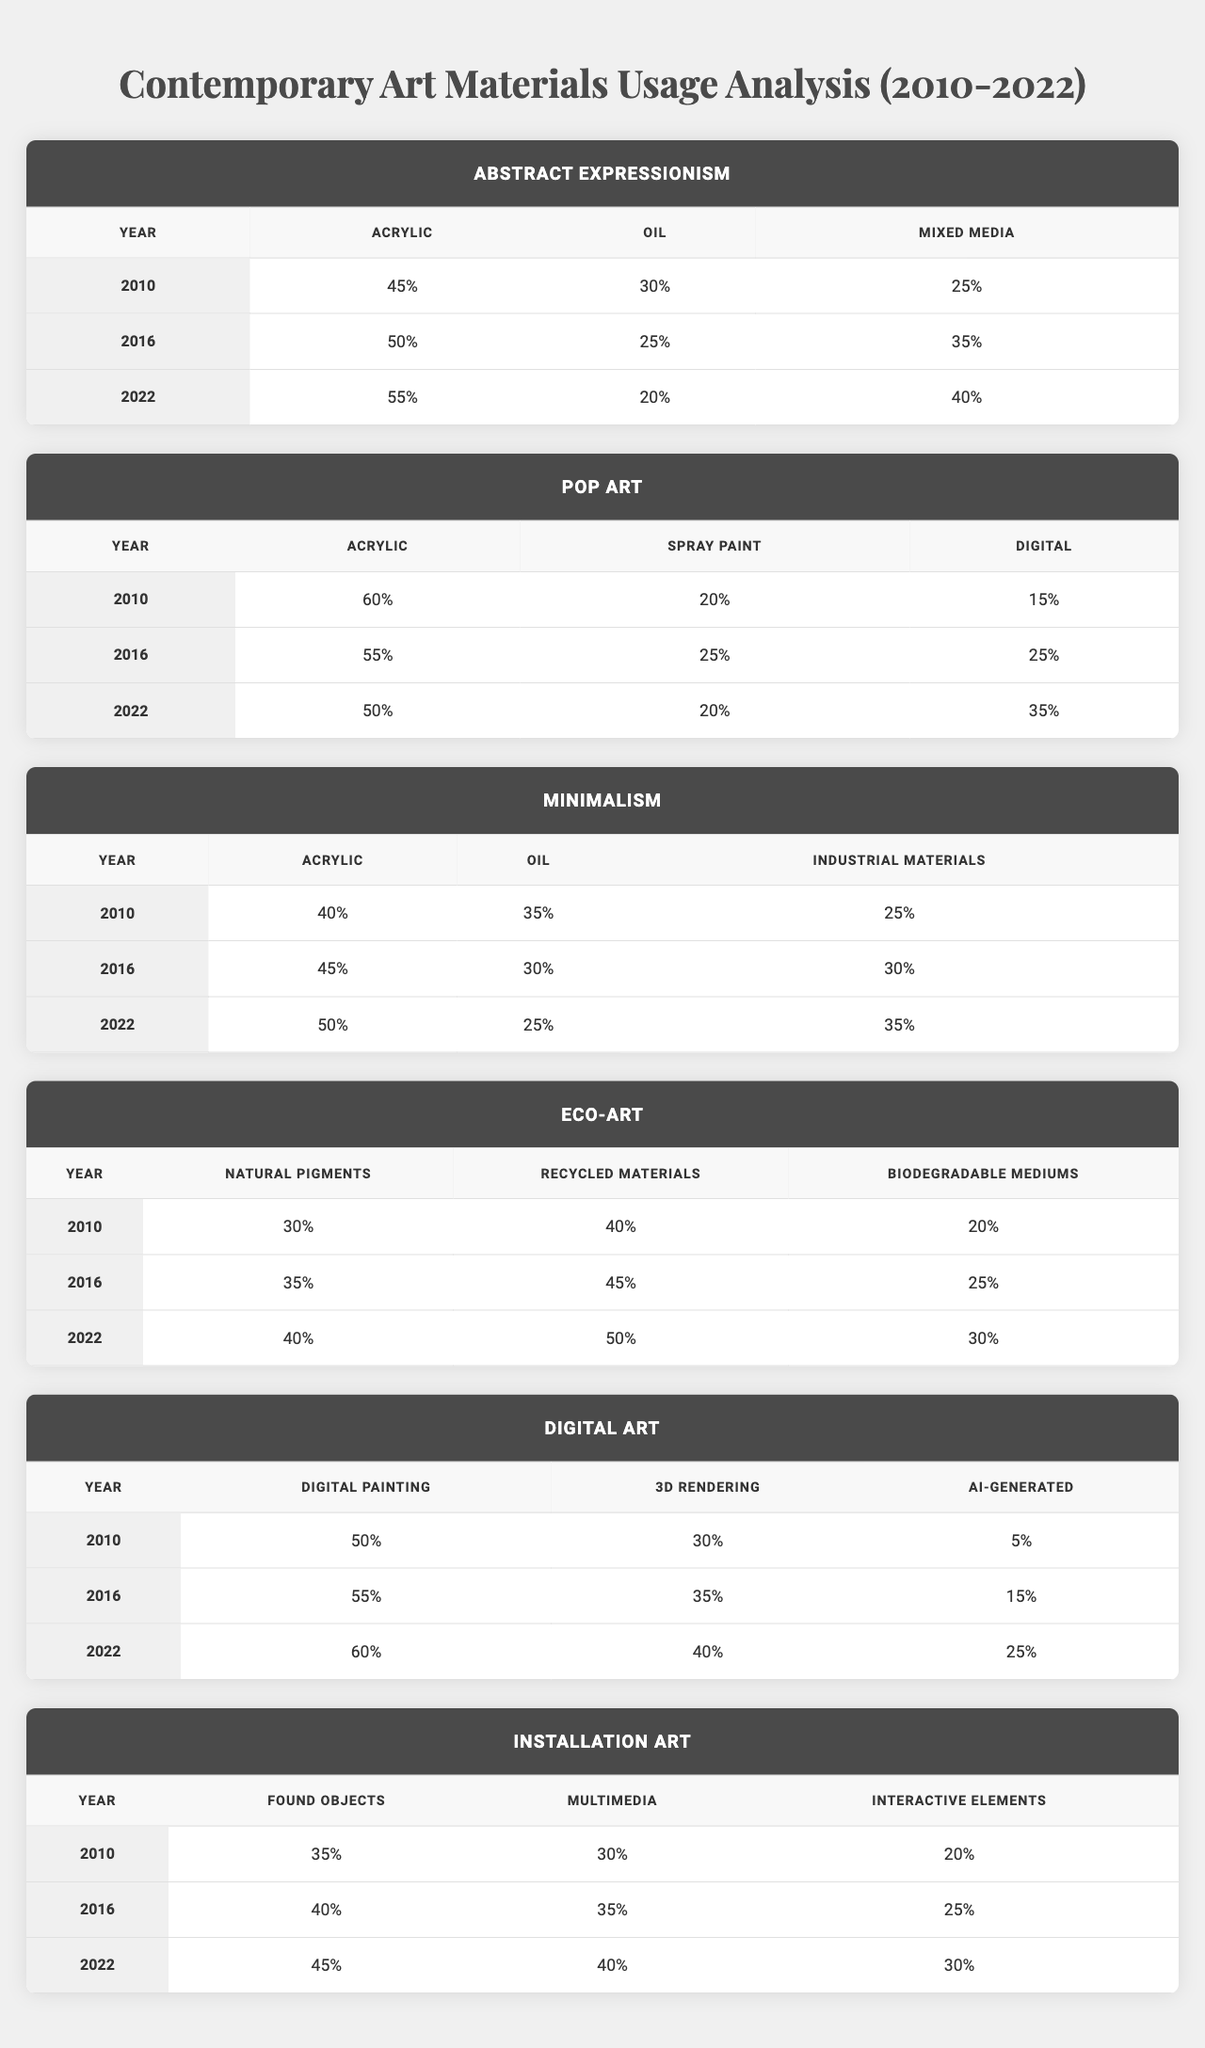What was the usage percentage of Acrylic in Abstract Expressionism in 2010? Referring to the table, the value for Acrylic in Abstract Expressionism for the year 2010 is 45%.
Answer: 45% What is the total percentage of materials used in Pop Art in 2016? For Pop Art in 2016, we have Acrylic (55%), Spray Paint (25%), and Digital (25%). Summing these gives us 55 + 25 + 25 = 105%.
Answer: 105% Was there an increase in the usage of Recycled Materials in Eco-Art from 2010 to 2022? In 2010, Recycled Materials were at 40%, and in 2022, they rose to 50%. Therefore, there was indeed an increase.
Answer: Yes What was the average usage percentage of Oil across all styles in 2016? Extracting the Oil percentages from each style for 2016: Abstract Expressionism (25%), Minimalism (30%), Eco-Art (not applicable), Pop Art (not applicable), and Digital Art (not applicable). Only three styles contain data: 25%, 30%, and we can calculate the average: (25 + 30) / 2 = 27.5%.
Answer: 27.5% In which style did the percentage of Mixed Media usage increase the most from 2010 to 2022? Looking at the Mixed Media values: Abstract Expressionism increased from 25% to 40%, Eco-Art (not applicable), and Digital Art (not applicable), and Installation Art (not applicable). Hence, the increase was 15% in Abstract Expressionism, which is the only relevant data.
Answer: Abstract Expressionism What was the percentage of Digital Painting in Digital Art in 2022? According to the table, the value for Digital Painting in Digital Art for the year 2022 is 60%.
Answer: 60% Which art style consistently used Acrylic the most throughout the years listed? Reviewing the data, Pop Art used the highest percentage of Acrylic at 60% in 2010, but it decreased to 50% by 2022. Abstract Expressionism started at 45% and increased to 55% in 2022, yet the highest usage is found in Pop Art for 2010.
Answer: Pop Art How did the usage of AI-Generated materials change from 2010 to 2022 in Digital Art? The percentage of AI-Generated materials increased from 5% in 2010 to 25% in 2022, indicating a significant growth of 20%.
Answer: Increased by 20% What was the percentage of Mixed Media in Abstract Expressionism in 2022? The table shows that the percentage of Mixed Media in Abstract Expressionism for the year 2022 is 40%.
Answer: 40% Which art style had the lowest percentage of Oil used in 2022? From the table for 2022, Minimalism shows Oil usage at 25%, which is lower than Abstract Expressionism (20%) and others, thus Minimalism had the lowest Oil percentage.
Answer: Minimalism 